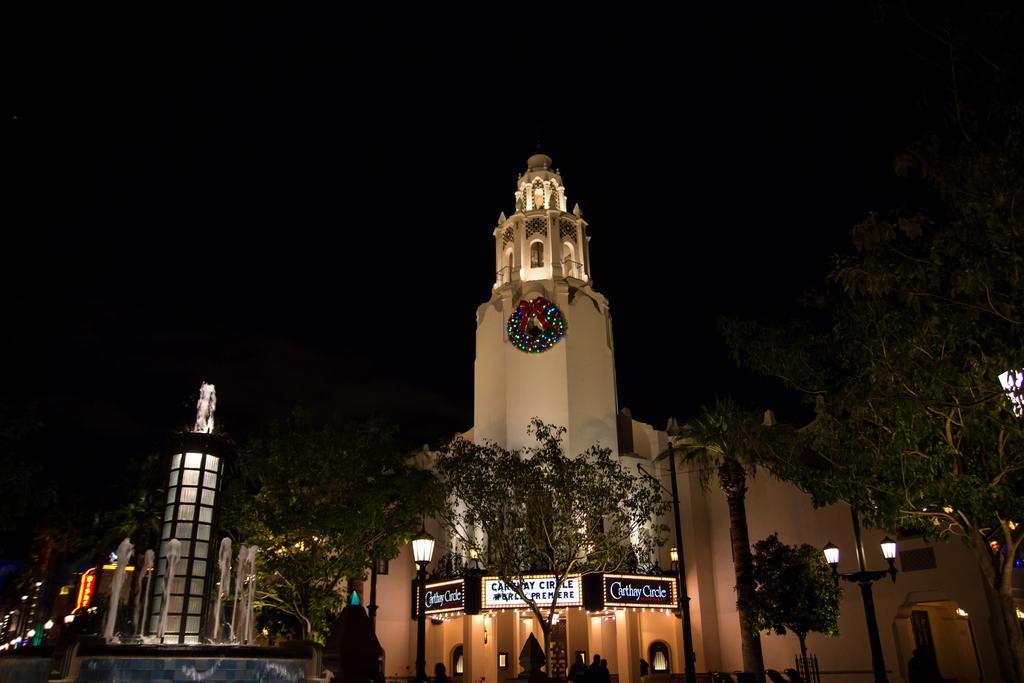In one or two sentences, can you explain what this image depicts? In this image, we can see some trees and poles in front of the building which is on the dark background. There is a fountain in the bottom left of the image. 